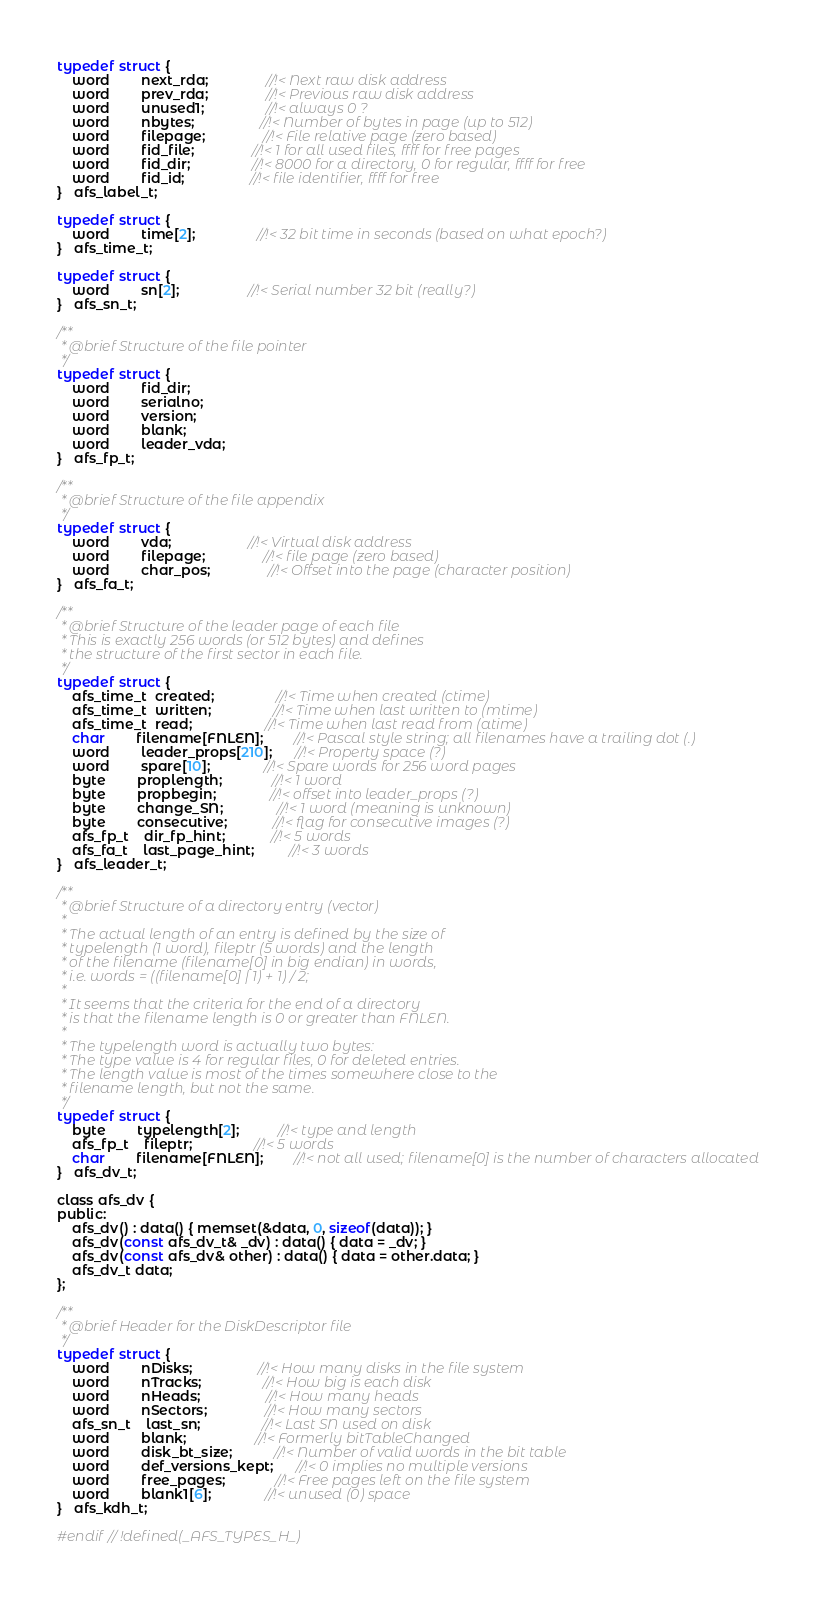<code> <loc_0><loc_0><loc_500><loc_500><_C_>typedef struct {
    word        next_rda;               //!< Next raw disk address
    word        prev_rda;               //!< Previous raw disk address
    word        unused1;                //!< always 0 ?
    word        nbytes;                 //!< Number of bytes in page (up to 512)
    word        filepage;               //!< File relative page (zero based)
    word        fid_file;               //!< 1 for all used files, ffff for free pages
    word        fid_dir;                //!< 8000 for a directory, 0 for regular, ffff for free
    word        fid_id;                 //!< file identifier, ffff for free
}   afs_label_t;

typedef struct {
    word        time[2];                //!< 32 bit time in seconds (based on what epoch?)
}   afs_time_t;

typedef struct {
    word        sn[2];                  //!< Serial number 32 bit (really?)
}   afs_sn_t;

/**
 * @brief Structure of the file pointer
 */
typedef struct {
    word        fid_dir;
    word        serialno;
    word        version;
    word        blank;
    word        leader_vda;
}   afs_fp_t;

/**
 * @brief Structure of the file appendix
 */
typedef struct {
    word        vda;                    //!< Virtual disk address
    word        filepage;               //!< file page (zero based)
    word        char_pos;               //!< Offset into the page (character position)
}   afs_fa_t;

/**
 * @brief Structure of the leader page of each file
 * This is exactly 256 words (or 512 bytes) and defines
 * the structure of the first sector in each file.
 */
typedef struct {
    afs_time_t  created;                //!< Time when created (ctime)
    afs_time_t  written;                //!< Time when last written to (mtime)
    afs_time_t  read;                   //!< Time when last read from (atime)
    char        filename[FNLEN];        //!< Pascal style string; all filenames have a trailing dot (.)
    word        leader_props[210];      //!< Property space (?)
    word        spare[10];              //!< Spare words for 256 word pages
    byte        proplength;             //!< 1 word
    byte        propbegin;              //!< offset into leader_props (?)
    byte        change_SN;              //!< 1 word (meaning is unknown)
    byte        consecutive;            //!< flag for consecutive images (?)
    afs_fp_t    dir_fp_hint;            //!< 5 words
    afs_fa_t    last_page_hint;         //!< 3 words
}   afs_leader_t;

/**
 * @brief Structure of a directory entry (vector)
 *
 * The actual length of an entry is defined by the size of
 * typelength (1 word), fileptr (5 words) and the length
 * of the filename (filename[0] in big endian) in words,
 * i.e. words = ((filename[0] | 1) + 1) / 2;
 *
 * It seems that the criteria for the end of a directory
 * is that the filename length is 0 or greater than FNLEN.
 *
 * The typelength word is actually two bytes:
 * The type value is 4 for regular files, 0 for deleted entries.
 * The length value is most of the times somewhere close to the
 * filename length, but not the same.
 */
typedef struct {
    byte        typelength[2];          //!< type and length
    afs_fp_t    fileptr;                //!< 5 words
    char        filename[FNLEN];        //!< not all used; filename[0] is the number of characters allocated
}   afs_dv_t;

class afs_dv {
public:
    afs_dv() : data() { memset(&data, 0, sizeof(data)); }
    afs_dv(const afs_dv_t& _dv) : data() { data = _dv; }
    afs_dv(const afs_dv& other) : data() { data = other.data; }
    afs_dv_t data;
};

/**
 * @brief Header for the DiskDescriptor file
 */
typedef struct {
    word        nDisks;                 //!< How many disks in the file system
    word        nTracks;                //!< How big is each disk
    word        nHeads;                 //!< How many heads
    word        nSectors;               //!< How many sectors
    afs_sn_t    last_sn;                //!< Last SN used on disk
    word        blank;                  //!< Formerly bitTableChanged
    word        disk_bt_size;           //!< Number of valid words in the bit table
    word        def_versions_kept;      //!< 0 implies no multiple versions
    word        free_pages;             //!< Free pages left on the file system
    word        blank1[6];              //!< unused (0) space
}   afs_kdh_t;

#endif // !defined(_AFS_TYPES_H_)
</code> 